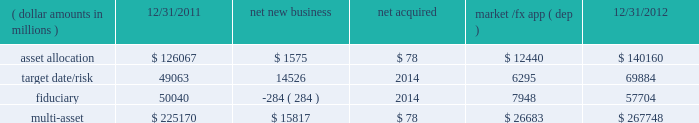Although many clients use both active and passive strategies , the application of these strategies differs greatly .
For example , clients may use index products to gain exposure to a market or asset class pending reallocation to an active manager .
This has the effect of increasing turnover of index aum .
In addition , institutional non-etp index assignments tend to be very large ( multi- billion dollars ) and typically reflect low fee rates .
This has the potential to exaggerate the significance of net flows in institutional index products on blackrock 2019s revenues and earnings .
Equity year-end 2012 equity aum of $ 1.845 trillion increased by $ 285.4 billion , or 18% ( 18 % ) , from the end of 2011 , largely due to flows into regional , country-specific and global mandates and the effect of higher market valuations .
Equity aum growth included $ 54.0 billion in net new business and $ 3.6 billion in new assets related to the acquisition of claymore .
Net new business of $ 54.0 billion was driven by net inflows of $ 53.0 billion and $ 19.1 billion into ishares and non-etp index accounts , respectively .
Passive inflows were offset by active net outflows of $ 18.1 billion , with net outflows of $ 10.0 billion and $ 8.1 billion from fundamental and scientific active equity products , respectively .
Passive strategies represented 84% ( 84 % ) of equity aum with the remaining 16% ( 16 % ) in active mandates .
Institutional investors represented 62% ( 62 % ) of equity aum , while ishares , and retail and hnw represented 29% ( 29 % ) and 9% ( 9 % ) , respectively .
At year-end 2012 , 63% ( 63 % ) of equity aum was managed for clients in the americas ( defined as the united states , caribbean , canada , latin america and iberia ) compared with 28% ( 28 % ) and 9% ( 9 % ) managed for clients in emea and asia-pacific , respectively .
Blackrock 2019s effective fee rates fluctuate due to changes in aum mix .
Approximately half of blackrock 2019s equity aum is tied to international markets , including emerging markets , which tend to have higher fee rates than similar u.s .
Equity strategies .
Accordingly , fluctuations in international equity markets , which do not consistently move in tandem with u.s .
Markets , may have a greater impact on blackrock 2019s effective equity fee rates and revenues .
Fixed income fixed income aum ended 2012 at $ 1.259 trillion , rising $ 11.6 billion , or 1% ( 1 % ) , relative to december 31 , 2011 .
Growth in aum reflected $ 43.3 billion in net new business , excluding the two large previously mentioned low-fee outflows , $ 75.4 billion in market and foreign exchange gains and $ 3.0 billion in new assets related to claymore .
Net new business was led by flows into domestic specialty and global bond mandates , with net inflows of $ 28.8 billion , $ 13.6 billion and $ 3.1 billion into ishares , non-etp index and model-based products , respectively , partially offset by net outflows of $ 2.2 billion from fundamental strategies .
Fixed income aum was split between passive and active strategies with 48% ( 48 % ) and 52% ( 52 % ) , respectively .
Institutional investors represented 74% ( 74 % ) of fixed income aum while ishares and retail and hnw represented 15% ( 15 % ) and 11% ( 11 % ) , respectively .
At year-end 2012 , 59% ( 59 % ) of fixed income aum was managed for clients in the americas compared with 33% ( 33 % ) and 8% ( 8 % ) managed for clients in emea and asia- pacific , respectively .
Multi-asset class component changes in multi-asset class aum ( dollar amounts in millions ) 12/31/2011 net new business acquired market /fx app ( dep ) 12/31/2012 .
Multi-asset class aum totaled $ 267.7 billion at year-end 2012 , up 19% ( 19 % ) , or $ 42.6 billion , reflecting $ 15.8 billion in net new business and $ 26.7 billion in portfolio valuation gains .
Blackrock 2019s multi-asset class team manages a variety of bespoke mandates for a diversified client base that leverages our broad investment expertise in global equities , currencies , bonds and commodities , and our extensive risk management capabilities .
Investment solutions might include a combination of long-only portfolios and alternative investments as well as tactical asset allocation overlays .
At december 31 , 2012 , institutional investors represented 66% ( 66 % ) of multi-asset class aum , while retail and hnw accounted for the remaining aum .
Additionally , 58% ( 58 % ) of multi-asset class aum is managed for clients based in the americas with 37% ( 37 % ) and 5% ( 5 % ) managed for clients in emea and asia-pacific , respectively .
Flows reflected ongoing institutional demand for our advice in an increasingly .
What is the percent change in asset allocation from 12/31/2011 to 12/31/2012? 
Computations: ((140160 - 126067) / 126067)
Answer: 0.11179. 